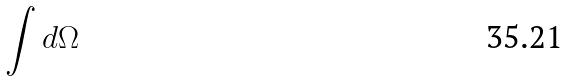Convert formula to latex. <formula><loc_0><loc_0><loc_500><loc_500>\int d \Omega</formula> 